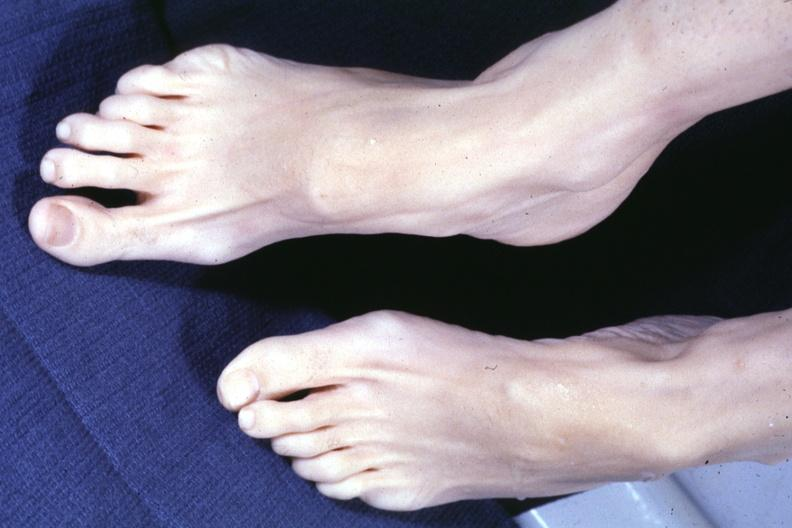s arachnodactyly present?
Answer the question using a single word or phrase. Yes 